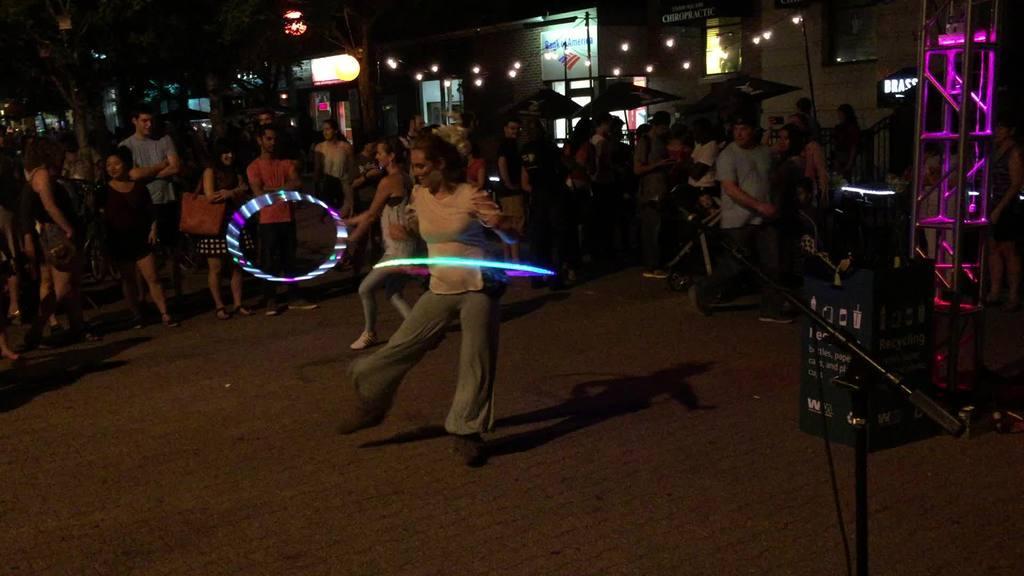Can you describe this image briefly? In this picture we can see some people standing , there is a woman holding a ring in the middle, in the background there are buildings and trees, we can see lights at the top of the picture, on the right side we can see a microphone, we can see hoardings in the background. 